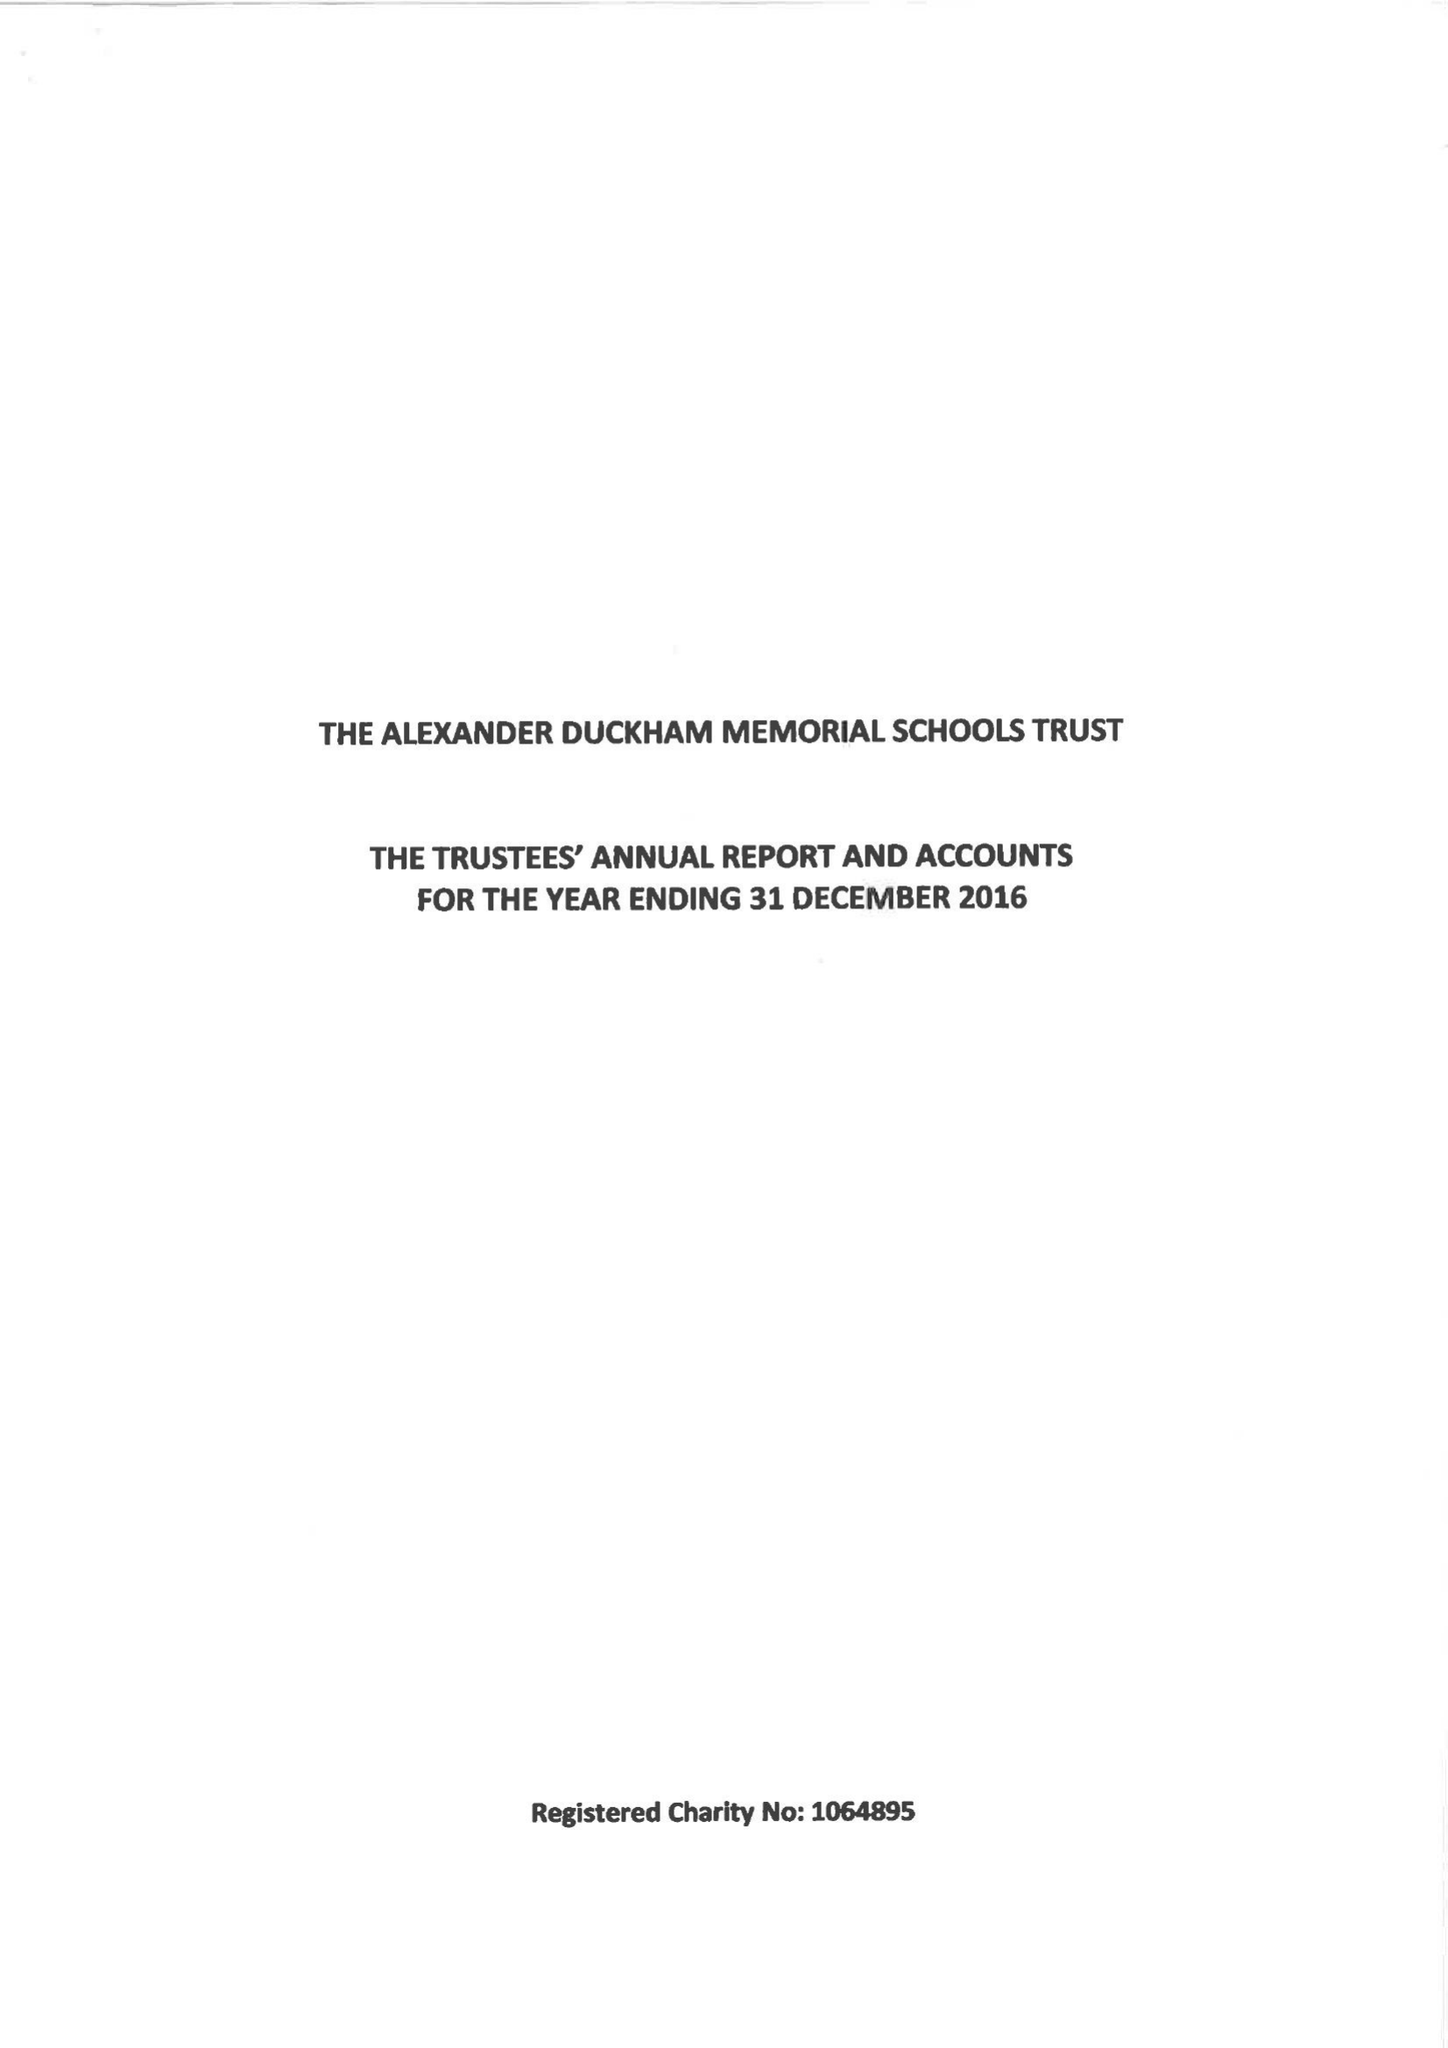What is the value for the address__street_line?
Answer the question using a single word or phrase. None 